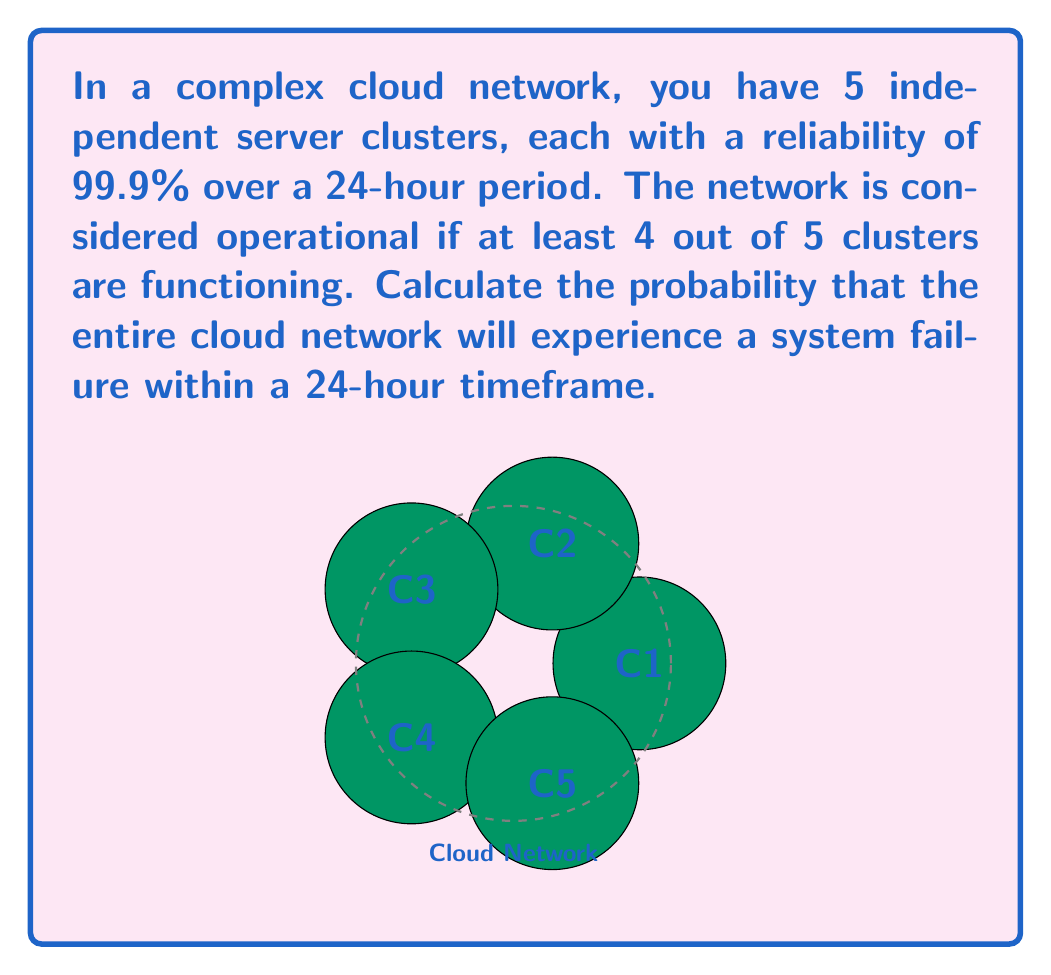Could you help me with this problem? Let's approach this step-by-step:

1) First, we need to understand what constitutes a system failure. The network fails if 2 or more clusters fail.

2) Let's define the probability of a single cluster failing:
   $p(\text{failure}) = 1 - 0.999 = 0.001$

3) We can use the binomial probability distribution to solve this. We want the probability of 2 or more failures out of 5 clusters.

4) The probability of exactly $k$ failures in $n$ trials is given by:
   $$P(X = k) = \binom{n}{k} p^k (1-p)^{n-k}$$
   where $p$ is the probability of failure for a single cluster.

5) We need to sum the probabilities for 2, 3, 4, and 5 failures:
   $$P(\text{system failure}) = P(X \geq 2) = P(X=2) + P(X=3) + P(X=4) + P(X=5)$$

6) Let's calculate each term:
   $$P(X=2) = \binom{5}{2} (0.001)^2 (0.999)^3 = 10 \cdot 10^{-6} \cdot 0.997 = 9.97 \cdot 10^{-6}$$
   $$P(X=3) = \binom{5}{3} (0.001)^3 (0.999)^2 = 10 \cdot 10^{-9} \cdot 0.998 = 9.98 \cdot 10^{-9}$$
   $$P(X=4) = \binom{5}{4} (0.001)^4 (0.999)^1 = 5 \cdot 10^{-12} \cdot 0.999 = 4.995 \cdot 10^{-12}$$
   $$P(X=5) = \binom{5}{5} (0.001)^5 (0.999)^0 = 10^{-15}$$

7) Sum these probabilities:
   $$P(\text{system failure}) = 9.97 \cdot 10^{-6} + 9.98 \cdot 10^{-9} + 4.995 \cdot 10^{-12} + 10^{-15} \approx 9.98 \cdot 10^{-6}$$
Answer: $9.98 \cdot 10^{-6}$ or approximately $0.00000998$ 